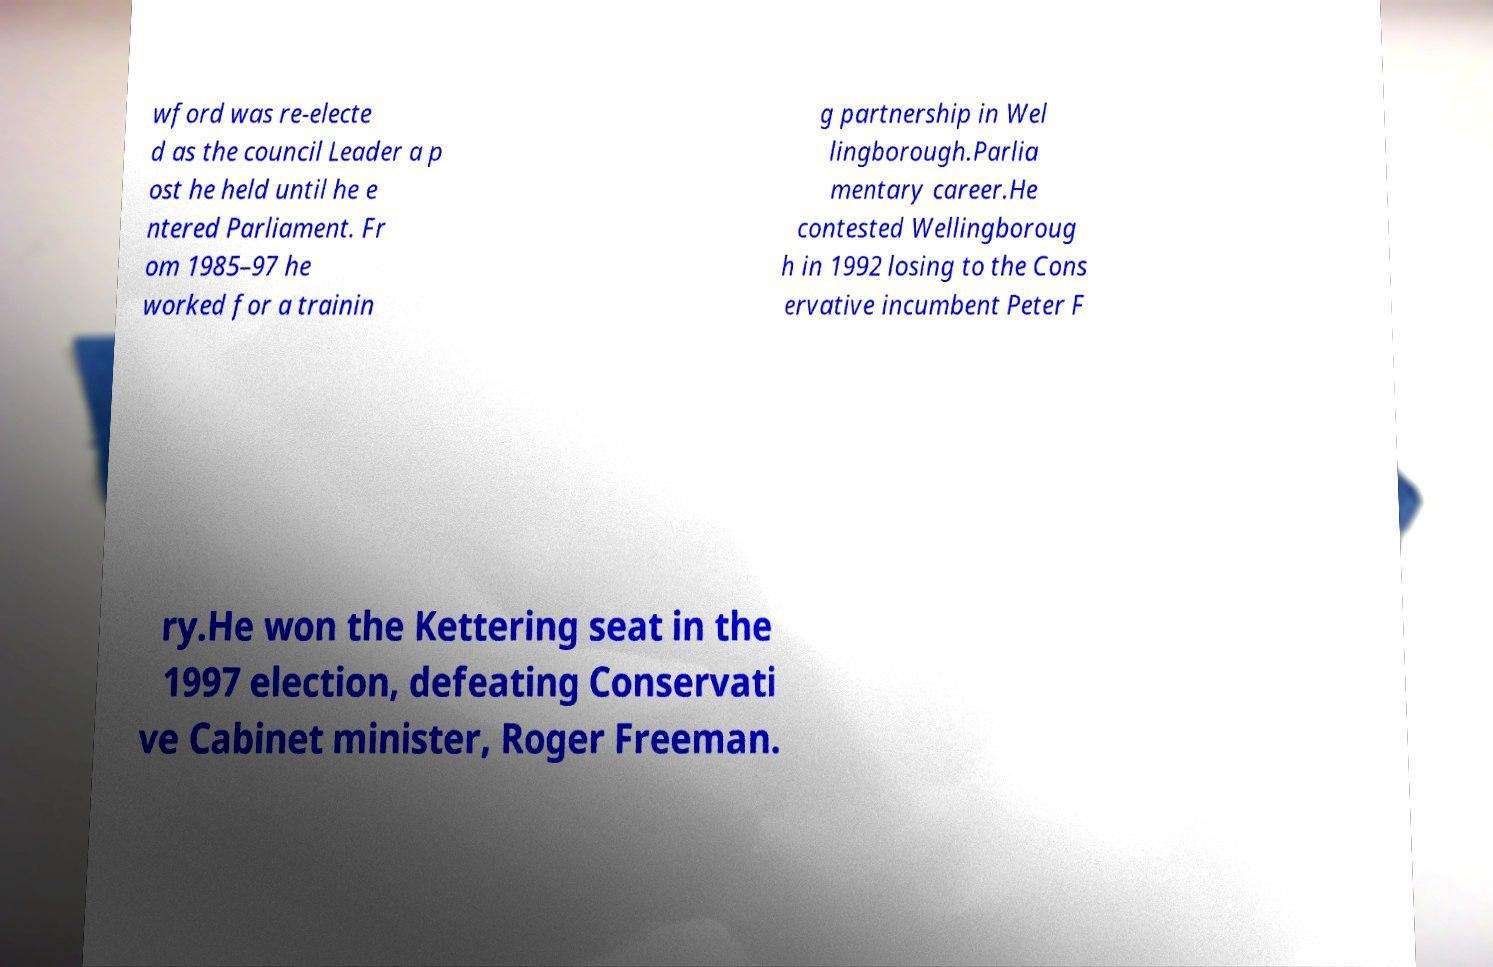Could you extract and type out the text from this image? wford was re-electe d as the council Leader a p ost he held until he e ntered Parliament. Fr om 1985–97 he worked for a trainin g partnership in Wel lingborough.Parlia mentary career.He contested Wellingboroug h in 1992 losing to the Cons ervative incumbent Peter F ry.He won the Kettering seat in the 1997 election, defeating Conservati ve Cabinet minister, Roger Freeman. 